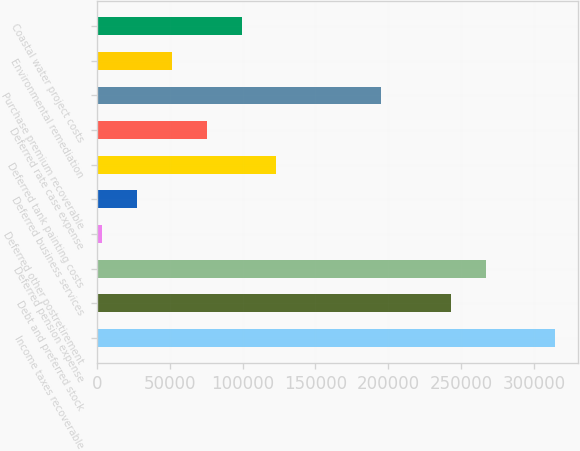<chart> <loc_0><loc_0><loc_500><loc_500><bar_chart><fcel>Income taxes recoverable<fcel>Debt and preferred stock<fcel>Deferred pension expense<fcel>Deferred other postretirement<fcel>Deferred business services<fcel>Deferred tank painting costs<fcel>Deferred rate case expense<fcel>Purchase premium recoverable<fcel>Environmental remediation<fcel>Coastal water project costs<nl><fcel>314677<fcel>242902<fcel>266827<fcel>3653<fcel>27577.9<fcel>123278<fcel>75427.7<fcel>195052<fcel>51502.8<fcel>99352.6<nl></chart> 